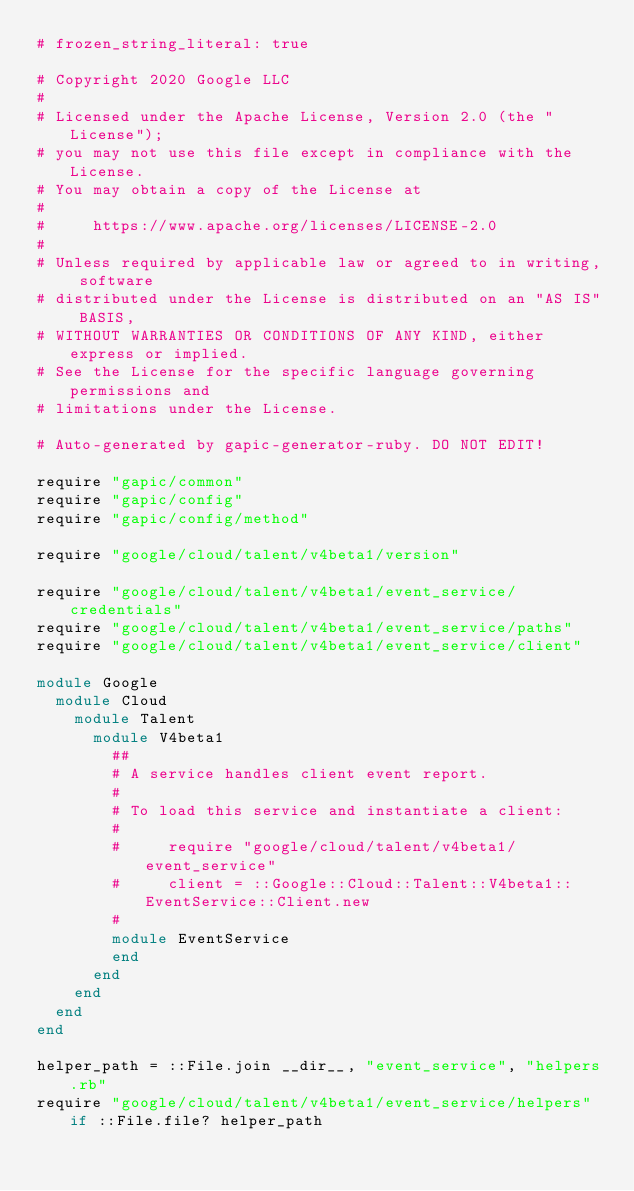Convert code to text. <code><loc_0><loc_0><loc_500><loc_500><_Ruby_># frozen_string_literal: true

# Copyright 2020 Google LLC
#
# Licensed under the Apache License, Version 2.0 (the "License");
# you may not use this file except in compliance with the License.
# You may obtain a copy of the License at
#
#     https://www.apache.org/licenses/LICENSE-2.0
#
# Unless required by applicable law or agreed to in writing, software
# distributed under the License is distributed on an "AS IS" BASIS,
# WITHOUT WARRANTIES OR CONDITIONS OF ANY KIND, either express or implied.
# See the License for the specific language governing permissions and
# limitations under the License.

# Auto-generated by gapic-generator-ruby. DO NOT EDIT!

require "gapic/common"
require "gapic/config"
require "gapic/config/method"

require "google/cloud/talent/v4beta1/version"

require "google/cloud/talent/v4beta1/event_service/credentials"
require "google/cloud/talent/v4beta1/event_service/paths"
require "google/cloud/talent/v4beta1/event_service/client"

module Google
  module Cloud
    module Talent
      module V4beta1
        ##
        # A service handles client event report.
        #
        # To load this service and instantiate a client:
        #
        #     require "google/cloud/talent/v4beta1/event_service"
        #     client = ::Google::Cloud::Talent::V4beta1::EventService::Client.new
        #
        module EventService
        end
      end
    end
  end
end

helper_path = ::File.join __dir__, "event_service", "helpers.rb"
require "google/cloud/talent/v4beta1/event_service/helpers" if ::File.file? helper_path
</code> 